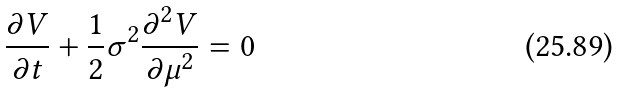Convert formula to latex. <formula><loc_0><loc_0><loc_500><loc_500>\frac { \partial V } { \partial t } + \frac { 1 } { 2 } \sigma ^ { 2 } \frac { \partial ^ { 2 } V } { \partial \mu ^ { 2 } } = 0</formula> 